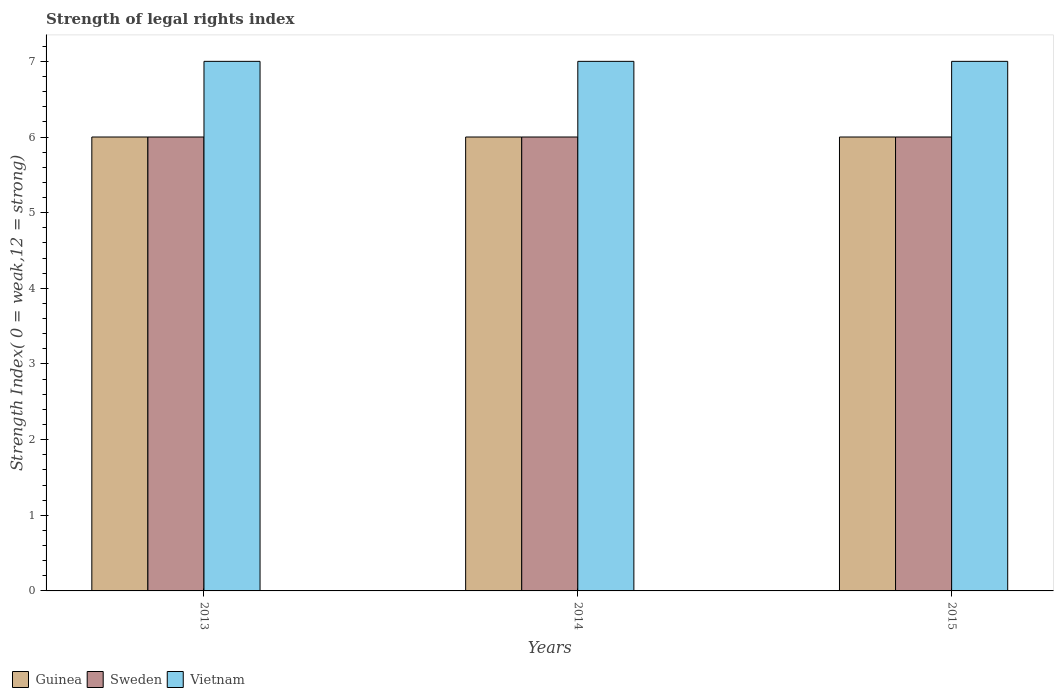Are the number of bars per tick equal to the number of legend labels?
Your response must be concise. Yes. In how many cases, is the number of bars for a given year not equal to the number of legend labels?
Your answer should be very brief. 0. What is the strength index in Vietnam in 2013?
Your answer should be compact. 7. Across all years, what is the maximum strength index in Guinea?
Make the answer very short. 6. Across all years, what is the minimum strength index in Vietnam?
Offer a terse response. 7. In which year was the strength index in Guinea maximum?
Your answer should be very brief. 2013. In which year was the strength index in Guinea minimum?
Provide a short and direct response. 2013. What is the total strength index in Guinea in the graph?
Your answer should be very brief. 18. What is the average strength index in Sweden per year?
Provide a succinct answer. 6. In the year 2014, what is the difference between the strength index in Sweden and strength index in Vietnam?
Offer a very short reply. -1. In how many years, is the strength index in Vietnam greater than 0.8?
Your response must be concise. 3. Is the strength index in Sweden in 2014 less than that in 2015?
Your response must be concise. No. What is the difference between the highest and the lowest strength index in Guinea?
Provide a short and direct response. 0. In how many years, is the strength index in Guinea greater than the average strength index in Guinea taken over all years?
Give a very brief answer. 0. What does the 3rd bar from the left in 2013 represents?
Give a very brief answer. Vietnam. How many bars are there?
Your answer should be very brief. 9. How many years are there in the graph?
Provide a succinct answer. 3. Does the graph contain any zero values?
Your response must be concise. No. Does the graph contain grids?
Give a very brief answer. No. Where does the legend appear in the graph?
Provide a succinct answer. Bottom left. How many legend labels are there?
Keep it short and to the point. 3. What is the title of the graph?
Keep it short and to the point. Strength of legal rights index. What is the label or title of the X-axis?
Keep it short and to the point. Years. What is the label or title of the Y-axis?
Offer a very short reply. Strength Index( 0 = weak,12 = strong). What is the Strength Index( 0 = weak,12 = strong) of Sweden in 2013?
Provide a short and direct response. 6. What is the Strength Index( 0 = weak,12 = strong) of Sweden in 2014?
Make the answer very short. 6. What is the Strength Index( 0 = weak,12 = strong) in Guinea in 2015?
Provide a succinct answer. 6. What is the Strength Index( 0 = weak,12 = strong) of Sweden in 2015?
Offer a terse response. 6. What is the Strength Index( 0 = weak,12 = strong) in Vietnam in 2015?
Provide a short and direct response. 7. Across all years, what is the maximum Strength Index( 0 = weak,12 = strong) of Guinea?
Keep it short and to the point. 6. Across all years, what is the maximum Strength Index( 0 = weak,12 = strong) in Sweden?
Your response must be concise. 6. Across all years, what is the maximum Strength Index( 0 = weak,12 = strong) in Vietnam?
Provide a succinct answer. 7. Across all years, what is the minimum Strength Index( 0 = weak,12 = strong) of Guinea?
Offer a terse response. 6. Across all years, what is the minimum Strength Index( 0 = weak,12 = strong) in Sweden?
Your answer should be compact. 6. Across all years, what is the minimum Strength Index( 0 = weak,12 = strong) in Vietnam?
Make the answer very short. 7. What is the total Strength Index( 0 = weak,12 = strong) in Guinea in the graph?
Make the answer very short. 18. What is the total Strength Index( 0 = weak,12 = strong) in Vietnam in the graph?
Provide a succinct answer. 21. What is the difference between the Strength Index( 0 = weak,12 = strong) of Vietnam in 2013 and that in 2015?
Make the answer very short. 0. What is the difference between the Strength Index( 0 = weak,12 = strong) in Guinea in 2014 and that in 2015?
Give a very brief answer. 0. What is the difference between the Strength Index( 0 = weak,12 = strong) in Vietnam in 2014 and that in 2015?
Offer a very short reply. 0. What is the difference between the Strength Index( 0 = weak,12 = strong) of Guinea in 2013 and the Strength Index( 0 = weak,12 = strong) of Sweden in 2014?
Provide a succinct answer. 0. What is the difference between the Strength Index( 0 = weak,12 = strong) in Sweden in 2013 and the Strength Index( 0 = weak,12 = strong) in Vietnam in 2014?
Provide a succinct answer. -1. What is the difference between the Strength Index( 0 = weak,12 = strong) in Guinea in 2013 and the Strength Index( 0 = weak,12 = strong) in Vietnam in 2015?
Provide a short and direct response. -1. What is the difference between the Strength Index( 0 = weak,12 = strong) in Guinea in 2014 and the Strength Index( 0 = weak,12 = strong) in Vietnam in 2015?
Provide a short and direct response. -1. What is the average Strength Index( 0 = weak,12 = strong) of Guinea per year?
Ensure brevity in your answer.  6. What is the average Strength Index( 0 = weak,12 = strong) in Vietnam per year?
Your response must be concise. 7. In the year 2013, what is the difference between the Strength Index( 0 = weak,12 = strong) in Guinea and Strength Index( 0 = weak,12 = strong) in Sweden?
Provide a short and direct response. 0. In the year 2013, what is the difference between the Strength Index( 0 = weak,12 = strong) in Guinea and Strength Index( 0 = weak,12 = strong) in Vietnam?
Your response must be concise. -1. In the year 2014, what is the difference between the Strength Index( 0 = weak,12 = strong) in Sweden and Strength Index( 0 = weak,12 = strong) in Vietnam?
Your response must be concise. -1. In the year 2015, what is the difference between the Strength Index( 0 = weak,12 = strong) of Guinea and Strength Index( 0 = weak,12 = strong) of Vietnam?
Your answer should be compact. -1. In the year 2015, what is the difference between the Strength Index( 0 = weak,12 = strong) in Sweden and Strength Index( 0 = weak,12 = strong) in Vietnam?
Offer a very short reply. -1. What is the ratio of the Strength Index( 0 = weak,12 = strong) in Sweden in 2013 to that in 2014?
Offer a terse response. 1. What is the ratio of the Strength Index( 0 = weak,12 = strong) in Vietnam in 2013 to that in 2014?
Provide a succinct answer. 1. What is the ratio of the Strength Index( 0 = weak,12 = strong) of Sweden in 2013 to that in 2015?
Provide a short and direct response. 1. What is the ratio of the Strength Index( 0 = weak,12 = strong) in Guinea in 2014 to that in 2015?
Keep it short and to the point. 1. What is the ratio of the Strength Index( 0 = weak,12 = strong) of Vietnam in 2014 to that in 2015?
Ensure brevity in your answer.  1. What is the difference between the highest and the lowest Strength Index( 0 = weak,12 = strong) in Guinea?
Your answer should be compact. 0. What is the difference between the highest and the lowest Strength Index( 0 = weak,12 = strong) in Vietnam?
Offer a terse response. 0. 